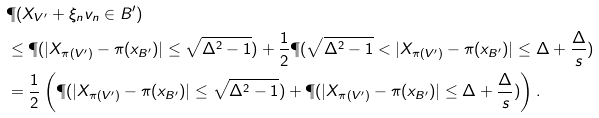Convert formula to latex. <formula><loc_0><loc_0><loc_500><loc_500>& \P ( X _ { V ^ { \prime } } + \xi _ { n } v _ { n } \in B ^ { \prime } ) \\ & \leq \P ( | X _ { \pi ( V ^ { \prime } ) } - \pi ( x _ { B ^ { \prime } } ) | \leq \sqrt { \Delta ^ { 2 } - 1 } ) + \frac { 1 } { 2 } \P ( \sqrt { \Delta ^ { 2 } - 1 } < | X _ { \pi ( V ^ { \prime } ) } - \pi ( x _ { B ^ { \prime } } ) | \leq \Delta + \frac { \Delta } { s } ) \\ & = \frac { 1 } { 2 } \left ( \P ( | X _ { \pi ( V ^ { \prime } ) } - \pi ( x _ { B ^ { \prime } } ) | \leq \sqrt { \Delta ^ { 2 } - 1 } ) + \P ( | X _ { \pi ( V ^ { \prime } ) } - \pi ( x _ { B ^ { \prime } } ) | \leq \Delta + \frac { \Delta } { s } ) \right ) .</formula> 